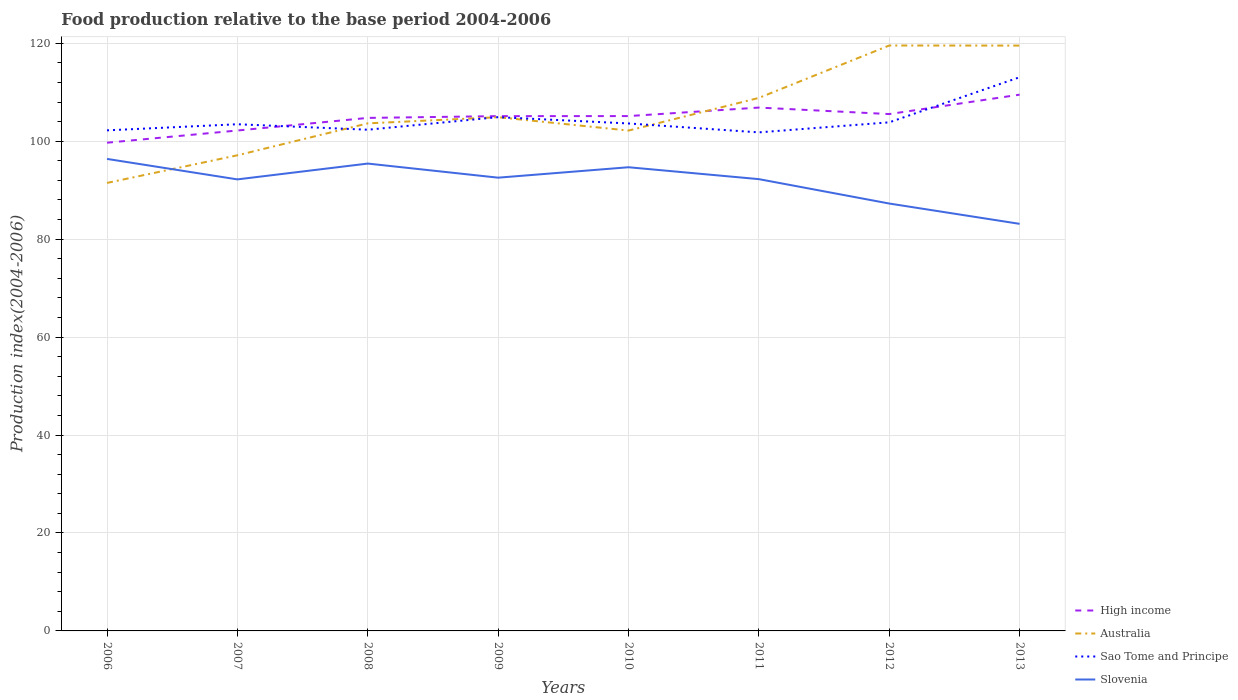How many different coloured lines are there?
Give a very brief answer. 4. Does the line corresponding to High income intersect with the line corresponding to Australia?
Provide a succinct answer. Yes. Across all years, what is the maximum food production index in Slovenia?
Provide a succinct answer. 83.12. In which year was the food production index in High income maximum?
Give a very brief answer. 2006. What is the total food production index in High income in the graph?
Keep it short and to the point. -3.96. What is the difference between the highest and the second highest food production index in High income?
Your answer should be compact. 9.81. How many years are there in the graph?
Give a very brief answer. 8. What is the difference between two consecutive major ticks on the Y-axis?
Your response must be concise. 20. Does the graph contain any zero values?
Ensure brevity in your answer.  No. Where does the legend appear in the graph?
Keep it short and to the point. Bottom right. How many legend labels are there?
Give a very brief answer. 4. How are the legend labels stacked?
Make the answer very short. Vertical. What is the title of the graph?
Make the answer very short. Food production relative to the base period 2004-2006. Does "Portugal" appear as one of the legend labels in the graph?
Keep it short and to the point. No. What is the label or title of the X-axis?
Give a very brief answer. Years. What is the label or title of the Y-axis?
Provide a short and direct response. Production index(2004-2006). What is the Production index(2004-2006) in High income in 2006?
Offer a terse response. 99.69. What is the Production index(2004-2006) of Australia in 2006?
Make the answer very short. 91.48. What is the Production index(2004-2006) of Sao Tome and Principe in 2006?
Keep it short and to the point. 102.21. What is the Production index(2004-2006) in Slovenia in 2006?
Make the answer very short. 96.38. What is the Production index(2004-2006) in High income in 2007?
Your answer should be compact. 102.18. What is the Production index(2004-2006) of Australia in 2007?
Offer a terse response. 97.12. What is the Production index(2004-2006) in Sao Tome and Principe in 2007?
Ensure brevity in your answer.  103.46. What is the Production index(2004-2006) of Slovenia in 2007?
Provide a succinct answer. 92.2. What is the Production index(2004-2006) in High income in 2008?
Your response must be concise. 104.75. What is the Production index(2004-2006) of Australia in 2008?
Keep it short and to the point. 103.64. What is the Production index(2004-2006) of Sao Tome and Principe in 2008?
Your answer should be compact. 102.34. What is the Production index(2004-2006) in Slovenia in 2008?
Your response must be concise. 95.43. What is the Production index(2004-2006) in High income in 2009?
Your response must be concise. 105.12. What is the Production index(2004-2006) of Australia in 2009?
Offer a terse response. 104.9. What is the Production index(2004-2006) of Sao Tome and Principe in 2009?
Offer a terse response. 104.91. What is the Production index(2004-2006) of Slovenia in 2009?
Provide a succinct answer. 92.55. What is the Production index(2004-2006) in High income in 2010?
Provide a short and direct response. 105.13. What is the Production index(2004-2006) of Australia in 2010?
Ensure brevity in your answer.  102.17. What is the Production index(2004-2006) in Sao Tome and Principe in 2010?
Your answer should be compact. 103.62. What is the Production index(2004-2006) of Slovenia in 2010?
Your answer should be very brief. 94.68. What is the Production index(2004-2006) of High income in 2011?
Your answer should be compact. 106.86. What is the Production index(2004-2006) of Australia in 2011?
Keep it short and to the point. 108.84. What is the Production index(2004-2006) in Sao Tome and Principe in 2011?
Offer a very short reply. 101.8. What is the Production index(2004-2006) in Slovenia in 2011?
Offer a terse response. 92.25. What is the Production index(2004-2006) of High income in 2012?
Your answer should be compact. 105.54. What is the Production index(2004-2006) of Australia in 2012?
Your answer should be very brief. 119.54. What is the Production index(2004-2006) of Sao Tome and Principe in 2012?
Your answer should be very brief. 103.85. What is the Production index(2004-2006) in Slovenia in 2012?
Provide a succinct answer. 87.27. What is the Production index(2004-2006) of High income in 2013?
Your answer should be compact. 109.5. What is the Production index(2004-2006) in Australia in 2013?
Your answer should be very brief. 119.52. What is the Production index(2004-2006) in Sao Tome and Principe in 2013?
Provide a succinct answer. 113.06. What is the Production index(2004-2006) in Slovenia in 2013?
Offer a very short reply. 83.12. Across all years, what is the maximum Production index(2004-2006) in High income?
Your response must be concise. 109.5. Across all years, what is the maximum Production index(2004-2006) of Australia?
Your response must be concise. 119.54. Across all years, what is the maximum Production index(2004-2006) in Sao Tome and Principe?
Keep it short and to the point. 113.06. Across all years, what is the maximum Production index(2004-2006) in Slovenia?
Your response must be concise. 96.38. Across all years, what is the minimum Production index(2004-2006) of High income?
Offer a very short reply. 99.69. Across all years, what is the minimum Production index(2004-2006) in Australia?
Keep it short and to the point. 91.48. Across all years, what is the minimum Production index(2004-2006) of Sao Tome and Principe?
Offer a terse response. 101.8. Across all years, what is the minimum Production index(2004-2006) of Slovenia?
Offer a terse response. 83.12. What is the total Production index(2004-2006) of High income in the graph?
Your response must be concise. 838.77. What is the total Production index(2004-2006) of Australia in the graph?
Make the answer very short. 847.21. What is the total Production index(2004-2006) of Sao Tome and Principe in the graph?
Offer a terse response. 835.25. What is the total Production index(2004-2006) of Slovenia in the graph?
Your answer should be very brief. 733.88. What is the difference between the Production index(2004-2006) of High income in 2006 and that in 2007?
Your response must be concise. -2.49. What is the difference between the Production index(2004-2006) in Australia in 2006 and that in 2007?
Offer a very short reply. -5.64. What is the difference between the Production index(2004-2006) in Sao Tome and Principe in 2006 and that in 2007?
Your answer should be very brief. -1.25. What is the difference between the Production index(2004-2006) in Slovenia in 2006 and that in 2007?
Ensure brevity in your answer.  4.18. What is the difference between the Production index(2004-2006) in High income in 2006 and that in 2008?
Offer a terse response. -5.06. What is the difference between the Production index(2004-2006) in Australia in 2006 and that in 2008?
Your answer should be compact. -12.16. What is the difference between the Production index(2004-2006) of Sao Tome and Principe in 2006 and that in 2008?
Keep it short and to the point. -0.13. What is the difference between the Production index(2004-2006) in Slovenia in 2006 and that in 2008?
Your answer should be very brief. 0.95. What is the difference between the Production index(2004-2006) of High income in 2006 and that in 2009?
Your answer should be very brief. -5.43. What is the difference between the Production index(2004-2006) in Australia in 2006 and that in 2009?
Provide a short and direct response. -13.42. What is the difference between the Production index(2004-2006) of Sao Tome and Principe in 2006 and that in 2009?
Give a very brief answer. -2.7. What is the difference between the Production index(2004-2006) of Slovenia in 2006 and that in 2009?
Give a very brief answer. 3.83. What is the difference between the Production index(2004-2006) in High income in 2006 and that in 2010?
Offer a terse response. -5.44. What is the difference between the Production index(2004-2006) of Australia in 2006 and that in 2010?
Give a very brief answer. -10.69. What is the difference between the Production index(2004-2006) in Sao Tome and Principe in 2006 and that in 2010?
Provide a succinct answer. -1.41. What is the difference between the Production index(2004-2006) of Slovenia in 2006 and that in 2010?
Offer a terse response. 1.7. What is the difference between the Production index(2004-2006) of High income in 2006 and that in 2011?
Offer a terse response. -7.17. What is the difference between the Production index(2004-2006) of Australia in 2006 and that in 2011?
Make the answer very short. -17.36. What is the difference between the Production index(2004-2006) in Sao Tome and Principe in 2006 and that in 2011?
Keep it short and to the point. 0.41. What is the difference between the Production index(2004-2006) in Slovenia in 2006 and that in 2011?
Give a very brief answer. 4.13. What is the difference between the Production index(2004-2006) of High income in 2006 and that in 2012?
Keep it short and to the point. -5.85. What is the difference between the Production index(2004-2006) in Australia in 2006 and that in 2012?
Provide a succinct answer. -28.06. What is the difference between the Production index(2004-2006) in Sao Tome and Principe in 2006 and that in 2012?
Your answer should be compact. -1.64. What is the difference between the Production index(2004-2006) of Slovenia in 2006 and that in 2012?
Your response must be concise. 9.11. What is the difference between the Production index(2004-2006) of High income in 2006 and that in 2013?
Your answer should be very brief. -9.81. What is the difference between the Production index(2004-2006) of Australia in 2006 and that in 2013?
Provide a short and direct response. -28.04. What is the difference between the Production index(2004-2006) in Sao Tome and Principe in 2006 and that in 2013?
Offer a very short reply. -10.85. What is the difference between the Production index(2004-2006) of Slovenia in 2006 and that in 2013?
Offer a very short reply. 13.26. What is the difference between the Production index(2004-2006) in High income in 2007 and that in 2008?
Provide a short and direct response. -2.57. What is the difference between the Production index(2004-2006) of Australia in 2007 and that in 2008?
Keep it short and to the point. -6.52. What is the difference between the Production index(2004-2006) in Sao Tome and Principe in 2007 and that in 2008?
Give a very brief answer. 1.12. What is the difference between the Production index(2004-2006) in Slovenia in 2007 and that in 2008?
Your answer should be very brief. -3.23. What is the difference between the Production index(2004-2006) of High income in 2007 and that in 2009?
Your response must be concise. -2.94. What is the difference between the Production index(2004-2006) of Australia in 2007 and that in 2009?
Offer a terse response. -7.78. What is the difference between the Production index(2004-2006) of Sao Tome and Principe in 2007 and that in 2009?
Give a very brief answer. -1.45. What is the difference between the Production index(2004-2006) in Slovenia in 2007 and that in 2009?
Provide a short and direct response. -0.35. What is the difference between the Production index(2004-2006) in High income in 2007 and that in 2010?
Your answer should be compact. -2.95. What is the difference between the Production index(2004-2006) in Australia in 2007 and that in 2010?
Provide a short and direct response. -5.05. What is the difference between the Production index(2004-2006) in Sao Tome and Principe in 2007 and that in 2010?
Your response must be concise. -0.16. What is the difference between the Production index(2004-2006) in Slovenia in 2007 and that in 2010?
Your answer should be compact. -2.48. What is the difference between the Production index(2004-2006) in High income in 2007 and that in 2011?
Offer a very short reply. -4.68. What is the difference between the Production index(2004-2006) in Australia in 2007 and that in 2011?
Your answer should be compact. -11.72. What is the difference between the Production index(2004-2006) of Sao Tome and Principe in 2007 and that in 2011?
Offer a very short reply. 1.66. What is the difference between the Production index(2004-2006) of Slovenia in 2007 and that in 2011?
Ensure brevity in your answer.  -0.05. What is the difference between the Production index(2004-2006) in High income in 2007 and that in 2012?
Provide a succinct answer. -3.36. What is the difference between the Production index(2004-2006) in Australia in 2007 and that in 2012?
Offer a very short reply. -22.42. What is the difference between the Production index(2004-2006) of Sao Tome and Principe in 2007 and that in 2012?
Offer a very short reply. -0.39. What is the difference between the Production index(2004-2006) of Slovenia in 2007 and that in 2012?
Your answer should be very brief. 4.93. What is the difference between the Production index(2004-2006) in High income in 2007 and that in 2013?
Your response must be concise. -7.32. What is the difference between the Production index(2004-2006) of Australia in 2007 and that in 2013?
Keep it short and to the point. -22.4. What is the difference between the Production index(2004-2006) in Slovenia in 2007 and that in 2013?
Provide a short and direct response. 9.08. What is the difference between the Production index(2004-2006) of High income in 2008 and that in 2009?
Provide a short and direct response. -0.36. What is the difference between the Production index(2004-2006) of Australia in 2008 and that in 2009?
Give a very brief answer. -1.26. What is the difference between the Production index(2004-2006) in Sao Tome and Principe in 2008 and that in 2009?
Offer a very short reply. -2.57. What is the difference between the Production index(2004-2006) of Slovenia in 2008 and that in 2009?
Keep it short and to the point. 2.88. What is the difference between the Production index(2004-2006) of High income in 2008 and that in 2010?
Ensure brevity in your answer.  -0.37. What is the difference between the Production index(2004-2006) in Australia in 2008 and that in 2010?
Provide a short and direct response. 1.47. What is the difference between the Production index(2004-2006) of Sao Tome and Principe in 2008 and that in 2010?
Your answer should be compact. -1.28. What is the difference between the Production index(2004-2006) of Slovenia in 2008 and that in 2010?
Offer a very short reply. 0.75. What is the difference between the Production index(2004-2006) of High income in 2008 and that in 2011?
Ensure brevity in your answer.  -2.11. What is the difference between the Production index(2004-2006) in Australia in 2008 and that in 2011?
Offer a terse response. -5.2. What is the difference between the Production index(2004-2006) in Sao Tome and Principe in 2008 and that in 2011?
Offer a terse response. 0.54. What is the difference between the Production index(2004-2006) in Slovenia in 2008 and that in 2011?
Offer a very short reply. 3.18. What is the difference between the Production index(2004-2006) in High income in 2008 and that in 2012?
Your answer should be very brief. -0.78. What is the difference between the Production index(2004-2006) in Australia in 2008 and that in 2012?
Provide a short and direct response. -15.9. What is the difference between the Production index(2004-2006) in Sao Tome and Principe in 2008 and that in 2012?
Your response must be concise. -1.51. What is the difference between the Production index(2004-2006) of Slovenia in 2008 and that in 2012?
Your answer should be compact. 8.16. What is the difference between the Production index(2004-2006) in High income in 2008 and that in 2013?
Ensure brevity in your answer.  -4.75. What is the difference between the Production index(2004-2006) of Australia in 2008 and that in 2013?
Give a very brief answer. -15.88. What is the difference between the Production index(2004-2006) in Sao Tome and Principe in 2008 and that in 2013?
Provide a short and direct response. -10.72. What is the difference between the Production index(2004-2006) in Slovenia in 2008 and that in 2013?
Offer a terse response. 12.31. What is the difference between the Production index(2004-2006) of High income in 2009 and that in 2010?
Offer a very short reply. -0.01. What is the difference between the Production index(2004-2006) in Australia in 2009 and that in 2010?
Offer a terse response. 2.73. What is the difference between the Production index(2004-2006) in Sao Tome and Principe in 2009 and that in 2010?
Your answer should be compact. 1.29. What is the difference between the Production index(2004-2006) of Slovenia in 2009 and that in 2010?
Your response must be concise. -2.13. What is the difference between the Production index(2004-2006) of High income in 2009 and that in 2011?
Ensure brevity in your answer.  -1.75. What is the difference between the Production index(2004-2006) in Australia in 2009 and that in 2011?
Provide a succinct answer. -3.94. What is the difference between the Production index(2004-2006) of Sao Tome and Principe in 2009 and that in 2011?
Your answer should be compact. 3.11. What is the difference between the Production index(2004-2006) in Slovenia in 2009 and that in 2011?
Ensure brevity in your answer.  0.3. What is the difference between the Production index(2004-2006) in High income in 2009 and that in 2012?
Give a very brief answer. -0.42. What is the difference between the Production index(2004-2006) in Australia in 2009 and that in 2012?
Ensure brevity in your answer.  -14.64. What is the difference between the Production index(2004-2006) in Sao Tome and Principe in 2009 and that in 2012?
Ensure brevity in your answer.  1.06. What is the difference between the Production index(2004-2006) of Slovenia in 2009 and that in 2012?
Your answer should be very brief. 5.28. What is the difference between the Production index(2004-2006) of High income in 2009 and that in 2013?
Provide a short and direct response. -4.39. What is the difference between the Production index(2004-2006) of Australia in 2009 and that in 2013?
Provide a succinct answer. -14.62. What is the difference between the Production index(2004-2006) of Sao Tome and Principe in 2009 and that in 2013?
Your response must be concise. -8.15. What is the difference between the Production index(2004-2006) in Slovenia in 2009 and that in 2013?
Keep it short and to the point. 9.43. What is the difference between the Production index(2004-2006) of High income in 2010 and that in 2011?
Offer a very short reply. -1.74. What is the difference between the Production index(2004-2006) in Australia in 2010 and that in 2011?
Give a very brief answer. -6.67. What is the difference between the Production index(2004-2006) in Sao Tome and Principe in 2010 and that in 2011?
Your response must be concise. 1.82. What is the difference between the Production index(2004-2006) in Slovenia in 2010 and that in 2011?
Your answer should be compact. 2.43. What is the difference between the Production index(2004-2006) in High income in 2010 and that in 2012?
Ensure brevity in your answer.  -0.41. What is the difference between the Production index(2004-2006) in Australia in 2010 and that in 2012?
Provide a succinct answer. -17.37. What is the difference between the Production index(2004-2006) of Sao Tome and Principe in 2010 and that in 2012?
Ensure brevity in your answer.  -0.23. What is the difference between the Production index(2004-2006) in Slovenia in 2010 and that in 2012?
Offer a terse response. 7.41. What is the difference between the Production index(2004-2006) in High income in 2010 and that in 2013?
Provide a succinct answer. -4.37. What is the difference between the Production index(2004-2006) of Australia in 2010 and that in 2013?
Ensure brevity in your answer.  -17.35. What is the difference between the Production index(2004-2006) in Sao Tome and Principe in 2010 and that in 2013?
Your response must be concise. -9.44. What is the difference between the Production index(2004-2006) of Slovenia in 2010 and that in 2013?
Ensure brevity in your answer.  11.56. What is the difference between the Production index(2004-2006) in High income in 2011 and that in 2012?
Your answer should be very brief. 1.33. What is the difference between the Production index(2004-2006) of Sao Tome and Principe in 2011 and that in 2012?
Provide a succinct answer. -2.05. What is the difference between the Production index(2004-2006) in Slovenia in 2011 and that in 2012?
Keep it short and to the point. 4.98. What is the difference between the Production index(2004-2006) of High income in 2011 and that in 2013?
Give a very brief answer. -2.64. What is the difference between the Production index(2004-2006) of Australia in 2011 and that in 2013?
Provide a succinct answer. -10.68. What is the difference between the Production index(2004-2006) of Sao Tome and Principe in 2011 and that in 2013?
Provide a succinct answer. -11.26. What is the difference between the Production index(2004-2006) of Slovenia in 2011 and that in 2013?
Your answer should be compact. 9.13. What is the difference between the Production index(2004-2006) in High income in 2012 and that in 2013?
Offer a terse response. -3.96. What is the difference between the Production index(2004-2006) in Australia in 2012 and that in 2013?
Your answer should be compact. 0.02. What is the difference between the Production index(2004-2006) in Sao Tome and Principe in 2012 and that in 2013?
Ensure brevity in your answer.  -9.21. What is the difference between the Production index(2004-2006) in Slovenia in 2012 and that in 2013?
Ensure brevity in your answer.  4.15. What is the difference between the Production index(2004-2006) of High income in 2006 and the Production index(2004-2006) of Australia in 2007?
Your answer should be very brief. 2.57. What is the difference between the Production index(2004-2006) of High income in 2006 and the Production index(2004-2006) of Sao Tome and Principe in 2007?
Your answer should be very brief. -3.77. What is the difference between the Production index(2004-2006) of High income in 2006 and the Production index(2004-2006) of Slovenia in 2007?
Give a very brief answer. 7.49. What is the difference between the Production index(2004-2006) in Australia in 2006 and the Production index(2004-2006) in Sao Tome and Principe in 2007?
Keep it short and to the point. -11.98. What is the difference between the Production index(2004-2006) of Australia in 2006 and the Production index(2004-2006) of Slovenia in 2007?
Your answer should be very brief. -0.72. What is the difference between the Production index(2004-2006) in Sao Tome and Principe in 2006 and the Production index(2004-2006) in Slovenia in 2007?
Your answer should be very brief. 10.01. What is the difference between the Production index(2004-2006) of High income in 2006 and the Production index(2004-2006) of Australia in 2008?
Make the answer very short. -3.95. What is the difference between the Production index(2004-2006) in High income in 2006 and the Production index(2004-2006) in Sao Tome and Principe in 2008?
Your answer should be compact. -2.65. What is the difference between the Production index(2004-2006) in High income in 2006 and the Production index(2004-2006) in Slovenia in 2008?
Your answer should be compact. 4.26. What is the difference between the Production index(2004-2006) of Australia in 2006 and the Production index(2004-2006) of Sao Tome and Principe in 2008?
Your answer should be compact. -10.86. What is the difference between the Production index(2004-2006) in Australia in 2006 and the Production index(2004-2006) in Slovenia in 2008?
Keep it short and to the point. -3.95. What is the difference between the Production index(2004-2006) of Sao Tome and Principe in 2006 and the Production index(2004-2006) of Slovenia in 2008?
Your answer should be compact. 6.78. What is the difference between the Production index(2004-2006) of High income in 2006 and the Production index(2004-2006) of Australia in 2009?
Provide a short and direct response. -5.21. What is the difference between the Production index(2004-2006) of High income in 2006 and the Production index(2004-2006) of Sao Tome and Principe in 2009?
Your response must be concise. -5.22. What is the difference between the Production index(2004-2006) in High income in 2006 and the Production index(2004-2006) in Slovenia in 2009?
Your answer should be compact. 7.14. What is the difference between the Production index(2004-2006) of Australia in 2006 and the Production index(2004-2006) of Sao Tome and Principe in 2009?
Keep it short and to the point. -13.43. What is the difference between the Production index(2004-2006) of Australia in 2006 and the Production index(2004-2006) of Slovenia in 2009?
Your answer should be compact. -1.07. What is the difference between the Production index(2004-2006) of Sao Tome and Principe in 2006 and the Production index(2004-2006) of Slovenia in 2009?
Keep it short and to the point. 9.66. What is the difference between the Production index(2004-2006) of High income in 2006 and the Production index(2004-2006) of Australia in 2010?
Your answer should be compact. -2.48. What is the difference between the Production index(2004-2006) of High income in 2006 and the Production index(2004-2006) of Sao Tome and Principe in 2010?
Provide a short and direct response. -3.93. What is the difference between the Production index(2004-2006) in High income in 2006 and the Production index(2004-2006) in Slovenia in 2010?
Your response must be concise. 5.01. What is the difference between the Production index(2004-2006) in Australia in 2006 and the Production index(2004-2006) in Sao Tome and Principe in 2010?
Provide a short and direct response. -12.14. What is the difference between the Production index(2004-2006) of Sao Tome and Principe in 2006 and the Production index(2004-2006) of Slovenia in 2010?
Provide a succinct answer. 7.53. What is the difference between the Production index(2004-2006) in High income in 2006 and the Production index(2004-2006) in Australia in 2011?
Keep it short and to the point. -9.15. What is the difference between the Production index(2004-2006) in High income in 2006 and the Production index(2004-2006) in Sao Tome and Principe in 2011?
Provide a succinct answer. -2.11. What is the difference between the Production index(2004-2006) in High income in 2006 and the Production index(2004-2006) in Slovenia in 2011?
Make the answer very short. 7.44. What is the difference between the Production index(2004-2006) in Australia in 2006 and the Production index(2004-2006) in Sao Tome and Principe in 2011?
Your answer should be compact. -10.32. What is the difference between the Production index(2004-2006) of Australia in 2006 and the Production index(2004-2006) of Slovenia in 2011?
Offer a very short reply. -0.77. What is the difference between the Production index(2004-2006) of Sao Tome and Principe in 2006 and the Production index(2004-2006) of Slovenia in 2011?
Provide a short and direct response. 9.96. What is the difference between the Production index(2004-2006) in High income in 2006 and the Production index(2004-2006) in Australia in 2012?
Keep it short and to the point. -19.85. What is the difference between the Production index(2004-2006) of High income in 2006 and the Production index(2004-2006) of Sao Tome and Principe in 2012?
Provide a succinct answer. -4.16. What is the difference between the Production index(2004-2006) of High income in 2006 and the Production index(2004-2006) of Slovenia in 2012?
Your answer should be compact. 12.42. What is the difference between the Production index(2004-2006) of Australia in 2006 and the Production index(2004-2006) of Sao Tome and Principe in 2012?
Give a very brief answer. -12.37. What is the difference between the Production index(2004-2006) in Australia in 2006 and the Production index(2004-2006) in Slovenia in 2012?
Provide a succinct answer. 4.21. What is the difference between the Production index(2004-2006) in Sao Tome and Principe in 2006 and the Production index(2004-2006) in Slovenia in 2012?
Your answer should be compact. 14.94. What is the difference between the Production index(2004-2006) in High income in 2006 and the Production index(2004-2006) in Australia in 2013?
Provide a short and direct response. -19.83. What is the difference between the Production index(2004-2006) of High income in 2006 and the Production index(2004-2006) of Sao Tome and Principe in 2013?
Make the answer very short. -13.37. What is the difference between the Production index(2004-2006) of High income in 2006 and the Production index(2004-2006) of Slovenia in 2013?
Ensure brevity in your answer.  16.57. What is the difference between the Production index(2004-2006) in Australia in 2006 and the Production index(2004-2006) in Sao Tome and Principe in 2013?
Give a very brief answer. -21.58. What is the difference between the Production index(2004-2006) in Australia in 2006 and the Production index(2004-2006) in Slovenia in 2013?
Provide a short and direct response. 8.36. What is the difference between the Production index(2004-2006) in Sao Tome and Principe in 2006 and the Production index(2004-2006) in Slovenia in 2013?
Your answer should be compact. 19.09. What is the difference between the Production index(2004-2006) of High income in 2007 and the Production index(2004-2006) of Australia in 2008?
Give a very brief answer. -1.46. What is the difference between the Production index(2004-2006) in High income in 2007 and the Production index(2004-2006) in Sao Tome and Principe in 2008?
Provide a succinct answer. -0.16. What is the difference between the Production index(2004-2006) of High income in 2007 and the Production index(2004-2006) of Slovenia in 2008?
Give a very brief answer. 6.75. What is the difference between the Production index(2004-2006) of Australia in 2007 and the Production index(2004-2006) of Sao Tome and Principe in 2008?
Make the answer very short. -5.22. What is the difference between the Production index(2004-2006) in Australia in 2007 and the Production index(2004-2006) in Slovenia in 2008?
Make the answer very short. 1.69. What is the difference between the Production index(2004-2006) in Sao Tome and Principe in 2007 and the Production index(2004-2006) in Slovenia in 2008?
Provide a short and direct response. 8.03. What is the difference between the Production index(2004-2006) of High income in 2007 and the Production index(2004-2006) of Australia in 2009?
Provide a succinct answer. -2.72. What is the difference between the Production index(2004-2006) in High income in 2007 and the Production index(2004-2006) in Sao Tome and Principe in 2009?
Your response must be concise. -2.73. What is the difference between the Production index(2004-2006) of High income in 2007 and the Production index(2004-2006) of Slovenia in 2009?
Offer a terse response. 9.63. What is the difference between the Production index(2004-2006) in Australia in 2007 and the Production index(2004-2006) in Sao Tome and Principe in 2009?
Make the answer very short. -7.79. What is the difference between the Production index(2004-2006) of Australia in 2007 and the Production index(2004-2006) of Slovenia in 2009?
Make the answer very short. 4.57. What is the difference between the Production index(2004-2006) of Sao Tome and Principe in 2007 and the Production index(2004-2006) of Slovenia in 2009?
Offer a terse response. 10.91. What is the difference between the Production index(2004-2006) of High income in 2007 and the Production index(2004-2006) of Australia in 2010?
Your response must be concise. 0.01. What is the difference between the Production index(2004-2006) in High income in 2007 and the Production index(2004-2006) in Sao Tome and Principe in 2010?
Provide a short and direct response. -1.44. What is the difference between the Production index(2004-2006) in High income in 2007 and the Production index(2004-2006) in Slovenia in 2010?
Provide a short and direct response. 7.5. What is the difference between the Production index(2004-2006) in Australia in 2007 and the Production index(2004-2006) in Sao Tome and Principe in 2010?
Provide a short and direct response. -6.5. What is the difference between the Production index(2004-2006) in Australia in 2007 and the Production index(2004-2006) in Slovenia in 2010?
Ensure brevity in your answer.  2.44. What is the difference between the Production index(2004-2006) in Sao Tome and Principe in 2007 and the Production index(2004-2006) in Slovenia in 2010?
Keep it short and to the point. 8.78. What is the difference between the Production index(2004-2006) in High income in 2007 and the Production index(2004-2006) in Australia in 2011?
Your response must be concise. -6.66. What is the difference between the Production index(2004-2006) in High income in 2007 and the Production index(2004-2006) in Sao Tome and Principe in 2011?
Your answer should be very brief. 0.38. What is the difference between the Production index(2004-2006) of High income in 2007 and the Production index(2004-2006) of Slovenia in 2011?
Your answer should be very brief. 9.93. What is the difference between the Production index(2004-2006) in Australia in 2007 and the Production index(2004-2006) in Sao Tome and Principe in 2011?
Provide a succinct answer. -4.68. What is the difference between the Production index(2004-2006) of Australia in 2007 and the Production index(2004-2006) of Slovenia in 2011?
Provide a short and direct response. 4.87. What is the difference between the Production index(2004-2006) in Sao Tome and Principe in 2007 and the Production index(2004-2006) in Slovenia in 2011?
Make the answer very short. 11.21. What is the difference between the Production index(2004-2006) of High income in 2007 and the Production index(2004-2006) of Australia in 2012?
Provide a succinct answer. -17.36. What is the difference between the Production index(2004-2006) of High income in 2007 and the Production index(2004-2006) of Sao Tome and Principe in 2012?
Offer a terse response. -1.67. What is the difference between the Production index(2004-2006) of High income in 2007 and the Production index(2004-2006) of Slovenia in 2012?
Make the answer very short. 14.91. What is the difference between the Production index(2004-2006) in Australia in 2007 and the Production index(2004-2006) in Sao Tome and Principe in 2012?
Your response must be concise. -6.73. What is the difference between the Production index(2004-2006) of Australia in 2007 and the Production index(2004-2006) of Slovenia in 2012?
Make the answer very short. 9.85. What is the difference between the Production index(2004-2006) in Sao Tome and Principe in 2007 and the Production index(2004-2006) in Slovenia in 2012?
Give a very brief answer. 16.19. What is the difference between the Production index(2004-2006) of High income in 2007 and the Production index(2004-2006) of Australia in 2013?
Offer a very short reply. -17.34. What is the difference between the Production index(2004-2006) in High income in 2007 and the Production index(2004-2006) in Sao Tome and Principe in 2013?
Your answer should be very brief. -10.88. What is the difference between the Production index(2004-2006) in High income in 2007 and the Production index(2004-2006) in Slovenia in 2013?
Your answer should be compact. 19.06. What is the difference between the Production index(2004-2006) in Australia in 2007 and the Production index(2004-2006) in Sao Tome and Principe in 2013?
Your answer should be compact. -15.94. What is the difference between the Production index(2004-2006) of Australia in 2007 and the Production index(2004-2006) of Slovenia in 2013?
Make the answer very short. 14. What is the difference between the Production index(2004-2006) in Sao Tome and Principe in 2007 and the Production index(2004-2006) in Slovenia in 2013?
Your answer should be very brief. 20.34. What is the difference between the Production index(2004-2006) of High income in 2008 and the Production index(2004-2006) of Australia in 2009?
Make the answer very short. -0.15. What is the difference between the Production index(2004-2006) of High income in 2008 and the Production index(2004-2006) of Sao Tome and Principe in 2009?
Your response must be concise. -0.16. What is the difference between the Production index(2004-2006) in High income in 2008 and the Production index(2004-2006) in Slovenia in 2009?
Ensure brevity in your answer.  12.2. What is the difference between the Production index(2004-2006) of Australia in 2008 and the Production index(2004-2006) of Sao Tome and Principe in 2009?
Make the answer very short. -1.27. What is the difference between the Production index(2004-2006) in Australia in 2008 and the Production index(2004-2006) in Slovenia in 2009?
Make the answer very short. 11.09. What is the difference between the Production index(2004-2006) in Sao Tome and Principe in 2008 and the Production index(2004-2006) in Slovenia in 2009?
Make the answer very short. 9.79. What is the difference between the Production index(2004-2006) in High income in 2008 and the Production index(2004-2006) in Australia in 2010?
Offer a terse response. 2.58. What is the difference between the Production index(2004-2006) in High income in 2008 and the Production index(2004-2006) in Sao Tome and Principe in 2010?
Offer a very short reply. 1.13. What is the difference between the Production index(2004-2006) of High income in 2008 and the Production index(2004-2006) of Slovenia in 2010?
Your response must be concise. 10.07. What is the difference between the Production index(2004-2006) of Australia in 2008 and the Production index(2004-2006) of Sao Tome and Principe in 2010?
Your answer should be compact. 0.02. What is the difference between the Production index(2004-2006) of Australia in 2008 and the Production index(2004-2006) of Slovenia in 2010?
Make the answer very short. 8.96. What is the difference between the Production index(2004-2006) in Sao Tome and Principe in 2008 and the Production index(2004-2006) in Slovenia in 2010?
Your answer should be very brief. 7.66. What is the difference between the Production index(2004-2006) in High income in 2008 and the Production index(2004-2006) in Australia in 2011?
Offer a very short reply. -4.09. What is the difference between the Production index(2004-2006) in High income in 2008 and the Production index(2004-2006) in Sao Tome and Principe in 2011?
Your answer should be compact. 2.95. What is the difference between the Production index(2004-2006) in High income in 2008 and the Production index(2004-2006) in Slovenia in 2011?
Offer a terse response. 12.5. What is the difference between the Production index(2004-2006) in Australia in 2008 and the Production index(2004-2006) in Sao Tome and Principe in 2011?
Offer a terse response. 1.84. What is the difference between the Production index(2004-2006) in Australia in 2008 and the Production index(2004-2006) in Slovenia in 2011?
Make the answer very short. 11.39. What is the difference between the Production index(2004-2006) of Sao Tome and Principe in 2008 and the Production index(2004-2006) of Slovenia in 2011?
Offer a terse response. 10.09. What is the difference between the Production index(2004-2006) of High income in 2008 and the Production index(2004-2006) of Australia in 2012?
Your response must be concise. -14.79. What is the difference between the Production index(2004-2006) of High income in 2008 and the Production index(2004-2006) of Sao Tome and Principe in 2012?
Ensure brevity in your answer.  0.9. What is the difference between the Production index(2004-2006) of High income in 2008 and the Production index(2004-2006) of Slovenia in 2012?
Provide a short and direct response. 17.48. What is the difference between the Production index(2004-2006) of Australia in 2008 and the Production index(2004-2006) of Sao Tome and Principe in 2012?
Your answer should be very brief. -0.21. What is the difference between the Production index(2004-2006) in Australia in 2008 and the Production index(2004-2006) in Slovenia in 2012?
Your answer should be very brief. 16.37. What is the difference between the Production index(2004-2006) of Sao Tome and Principe in 2008 and the Production index(2004-2006) of Slovenia in 2012?
Your response must be concise. 15.07. What is the difference between the Production index(2004-2006) of High income in 2008 and the Production index(2004-2006) of Australia in 2013?
Offer a terse response. -14.77. What is the difference between the Production index(2004-2006) of High income in 2008 and the Production index(2004-2006) of Sao Tome and Principe in 2013?
Provide a succinct answer. -8.31. What is the difference between the Production index(2004-2006) in High income in 2008 and the Production index(2004-2006) in Slovenia in 2013?
Offer a very short reply. 21.63. What is the difference between the Production index(2004-2006) of Australia in 2008 and the Production index(2004-2006) of Sao Tome and Principe in 2013?
Make the answer very short. -9.42. What is the difference between the Production index(2004-2006) in Australia in 2008 and the Production index(2004-2006) in Slovenia in 2013?
Your answer should be very brief. 20.52. What is the difference between the Production index(2004-2006) in Sao Tome and Principe in 2008 and the Production index(2004-2006) in Slovenia in 2013?
Provide a short and direct response. 19.22. What is the difference between the Production index(2004-2006) of High income in 2009 and the Production index(2004-2006) of Australia in 2010?
Your answer should be compact. 2.95. What is the difference between the Production index(2004-2006) of High income in 2009 and the Production index(2004-2006) of Sao Tome and Principe in 2010?
Provide a short and direct response. 1.5. What is the difference between the Production index(2004-2006) of High income in 2009 and the Production index(2004-2006) of Slovenia in 2010?
Provide a short and direct response. 10.44. What is the difference between the Production index(2004-2006) in Australia in 2009 and the Production index(2004-2006) in Sao Tome and Principe in 2010?
Give a very brief answer. 1.28. What is the difference between the Production index(2004-2006) of Australia in 2009 and the Production index(2004-2006) of Slovenia in 2010?
Make the answer very short. 10.22. What is the difference between the Production index(2004-2006) of Sao Tome and Principe in 2009 and the Production index(2004-2006) of Slovenia in 2010?
Give a very brief answer. 10.23. What is the difference between the Production index(2004-2006) in High income in 2009 and the Production index(2004-2006) in Australia in 2011?
Offer a terse response. -3.72. What is the difference between the Production index(2004-2006) in High income in 2009 and the Production index(2004-2006) in Sao Tome and Principe in 2011?
Ensure brevity in your answer.  3.32. What is the difference between the Production index(2004-2006) of High income in 2009 and the Production index(2004-2006) of Slovenia in 2011?
Your answer should be very brief. 12.87. What is the difference between the Production index(2004-2006) of Australia in 2009 and the Production index(2004-2006) of Slovenia in 2011?
Provide a short and direct response. 12.65. What is the difference between the Production index(2004-2006) of Sao Tome and Principe in 2009 and the Production index(2004-2006) of Slovenia in 2011?
Keep it short and to the point. 12.66. What is the difference between the Production index(2004-2006) in High income in 2009 and the Production index(2004-2006) in Australia in 2012?
Your answer should be very brief. -14.42. What is the difference between the Production index(2004-2006) in High income in 2009 and the Production index(2004-2006) in Sao Tome and Principe in 2012?
Your answer should be compact. 1.27. What is the difference between the Production index(2004-2006) in High income in 2009 and the Production index(2004-2006) in Slovenia in 2012?
Your response must be concise. 17.85. What is the difference between the Production index(2004-2006) in Australia in 2009 and the Production index(2004-2006) in Sao Tome and Principe in 2012?
Offer a very short reply. 1.05. What is the difference between the Production index(2004-2006) in Australia in 2009 and the Production index(2004-2006) in Slovenia in 2012?
Ensure brevity in your answer.  17.63. What is the difference between the Production index(2004-2006) of Sao Tome and Principe in 2009 and the Production index(2004-2006) of Slovenia in 2012?
Provide a short and direct response. 17.64. What is the difference between the Production index(2004-2006) of High income in 2009 and the Production index(2004-2006) of Australia in 2013?
Keep it short and to the point. -14.4. What is the difference between the Production index(2004-2006) of High income in 2009 and the Production index(2004-2006) of Sao Tome and Principe in 2013?
Your response must be concise. -7.94. What is the difference between the Production index(2004-2006) of High income in 2009 and the Production index(2004-2006) of Slovenia in 2013?
Offer a very short reply. 22. What is the difference between the Production index(2004-2006) of Australia in 2009 and the Production index(2004-2006) of Sao Tome and Principe in 2013?
Your answer should be compact. -8.16. What is the difference between the Production index(2004-2006) of Australia in 2009 and the Production index(2004-2006) of Slovenia in 2013?
Make the answer very short. 21.78. What is the difference between the Production index(2004-2006) of Sao Tome and Principe in 2009 and the Production index(2004-2006) of Slovenia in 2013?
Ensure brevity in your answer.  21.79. What is the difference between the Production index(2004-2006) in High income in 2010 and the Production index(2004-2006) in Australia in 2011?
Make the answer very short. -3.71. What is the difference between the Production index(2004-2006) of High income in 2010 and the Production index(2004-2006) of Sao Tome and Principe in 2011?
Give a very brief answer. 3.33. What is the difference between the Production index(2004-2006) of High income in 2010 and the Production index(2004-2006) of Slovenia in 2011?
Offer a terse response. 12.88. What is the difference between the Production index(2004-2006) of Australia in 2010 and the Production index(2004-2006) of Sao Tome and Principe in 2011?
Make the answer very short. 0.37. What is the difference between the Production index(2004-2006) in Australia in 2010 and the Production index(2004-2006) in Slovenia in 2011?
Provide a short and direct response. 9.92. What is the difference between the Production index(2004-2006) of Sao Tome and Principe in 2010 and the Production index(2004-2006) of Slovenia in 2011?
Provide a succinct answer. 11.37. What is the difference between the Production index(2004-2006) in High income in 2010 and the Production index(2004-2006) in Australia in 2012?
Provide a succinct answer. -14.41. What is the difference between the Production index(2004-2006) in High income in 2010 and the Production index(2004-2006) in Sao Tome and Principe in 2012?
Ensure brevity in your answer.  1.28. What is the difference between the Production index(2004-2006) in High income in 2010 and the Production index(2004-2006) in Slovenia in 2012?
Offer a terse response. 17.86. What is the difference between the Production index(2004-2006) of Australia in 2010 and the Production index(2004-2006) of Sao Tome and Principe in 2012?
Your response must be concise. -1.68. What is the difference between the Production index(2004-2006) of Australia in 2010 and the Production index(2004-2006) of Slovenia in 2012?
Your response must be concise. 14.9. What is the difference between the Production index(2004-2006) in Sao Tome and Principe in 2010 and the Production index(2004-2006) in Slovenia in 2012?
Provide a succinct answer. 16.35. What is the difference between the Production index(2004-2006) in High income in 2010 and the Production index(2004-2006) in Australia in 2013?
Offer a terse response. -14.39. What is the difference between the Production index(2004-2006) in High income in 2010 and the Production index(2004-2006) in Sao Tome and Principe in 2013?
Provide a short and direct response. -7.93. What is the difference between the Production index(2004-2006) of High income in 2010 and the Production index(2004-2006) of Slovenia in 2013?
Make the answer very short. 22.01. What is the difference between the Production index(2004-2006) in Australia in 2010 and the Production index(2004-2006) in Sao Tome and Principe in 2013?
Your response must be concise. -10.89. What is the difference between the Production index(2004-2006) in Australia in 2010 and the Production index(2004-2006) in Slovenia in 2013?
Provide a succinct answer. 19.05. What is the difference between the Production index(2004-2006) in High income in 2011 and the Production index(2004-2006) in Australia in 2012?
Offer a very short reply. -12.68. What is the difference between the Production index(2004-2006) of High income in 2011 and the Production index(2004-2006) of Sao Tome and Principe in 2012?
Keep it short and to the point. 3.01. What is the difference between the Production index(2004-2006) in High income in 2011 and the Production index(2004-2006) in Slovenia in 2012?
Your answer should be very brief. 19.59. What is the difference between the Production index(2004-2006) in Australia in 2011 and the Production index(2004-2006) in Sao Tome and Principe in 2012?
Give a very brief answer. 4.99. What is the difference between the Production index(2004-2006) of Australia in 2011 and the Production index(2004-2006) of Slovenia in 2012?
Your answer should be compact. 21.57. What is the difference between the Production index(2004-2006) of Sao Tome and Principe in 2011 and the Production index(2004-2006) of Slovenia in 2012?
Your answer should be very brief. 14.53. What is the difference between the Production index(2004-2006) in High income in 2011 and the Production index(2004-2006) in Australia in 2013?
Provide a short and direct response. -12.66. What is the difference between the Production index(2004-2006) of High income in 2011 and the Production index(2004-2006) of Sao Tome and Principe in 2013?
Your answer should be compact. -6.2. What is the difference between the Production index(2004-2006) in High income in 2011 and the Production index(2004-2006) in Slovenia in 2013?
Offer a terse response. 23.74. What is the difference between the Production index(2004-2006) in Australia in 2011 and the Production index(2004-2006) in Sao Tome and Principe in 2013?
Ensure brevity in your answer.  -4.22. What is the difference between the Production index(2004-2006) of Australia in 2011 and the Production index(2004-2006) of Slovenia in 2013?
Give a very brief answer. 25.72. What is the difference between the Production index(2004-2006) of Sao Tome and Principe in 2011 and the Production index(2004-2006) of Slovenia in 2013?
Provide a succinct answer. 18.68. What is the difference between the Production index(2004-2006) in High income in 2012 and the Production index(2004-2006) in Australia in 2013?
Your answer should be very brief. -13.98. What is the difference between the Production index(2004-2006) of High income in 2012 and the Production index(2004-2006) of Sao Tome and Principe in 2013?
Provide a succinct answer. -7.52. What is the difference between the Production index(2004-2006) of High income in 2012 and the Production index(2004-2006) of Slovenia in 2013?
Your answer should be very brief. 22.42. What is the difference between the Production index(2004-2006) in Australia in 2012 and the Production index(2004-2006) in Sao Tome and Principe in 2013?
Your response must be concise. 6.48. What is the difference between the Production index(2004-2006) in Australia in 2012 and the Production index(2004-2006) in Slovenia in 2013?
Provide a succinct answer. 36.42. What is the difference between the Production index(2004-2006) in Sao Tome and Principe in 2012 and the Production index(2004-2006) in Slovenia in 2013?
Provide a short and direct response. 20.73. What is the average Production index(2004-2006) in High income per year?
Offer a very short reply. 104.85. What is the average Production index(2004-2006) in Australia per year?
Provide a short and direct response. 105.9. What is the average Production index(2004-2006) in Sao Tome and Principe per year?
Offer a terse response. 104.41. What is the average Production index(2004-2006) in Slovenia per year?
Give a very brief answer. 91.73. In the year 2006, what is the difference between the Production index(2004-2006) of High income and Production index(2004-2006) of Australia?
Keep it short and to the point. 8.21. In the year 2006, what is the difference between the Production index(2004-2006) of High income and Production index(2004-2006) of Sao Tome and Principe?
Offer a terse response. -2.52. In the year 2006, what is the difference between the Production index(2004-2006) in High income and Production index(2004-2006) in Slovenia?
Provide a short and direct response. 3.31. In the year 2006, what is the difference between the Production index(2004-2006) of Australia and Production index(2004-2006) of Sao Tome and Principe?
Make the answer very short. -10.73. In the year 2006, what is the difference between the Production index(2004-2006) of Sao Tome and Principe and Production index(2004-2006) of Slovenia?
Provide a succinct answer. 5.83. In the year 2007, what is the difference between the Production index(2004-2006) of High income and Production index(2004-2006) of Australia?
Provide a succinct answer. 5.06. In the year 2007, what is the difference between the Production index(2004-2006) of High income and Production index(2004-2006) of Sao Tome and Principe?
Your response must be concise. -1.28. In the year 2007, what is the difference between the Production index(2004-2006) in High income and Production index(2004-2006) in Slovenia?
Provide a succinct answer. 9.98. In the year 2007, what is the difference between the Production index(2004-2006) in Australia and Production index(2004-2006) in Sao Tome and Principe?
Make the answer very short. -6.34. In the year 2007, what is the difference between the Production index(2004-2006) of Australia and Production index(2004-2006) of Slovenia?
Make the answer very short. 4.92. In the year 2007, what is the difference between the Production index(2004-2006) in Sao Tome and Principe and Production index(2004-2006) in Slovenia?
Your response must be concise. 11.26. In the year 2008, what is the difference between the Production index(2004-2006) in High income and Production index(2004-2006) in Australia?
Provide a succinct answer. 1.11. In the year 2008, what is the difference between the Production index(2004-2006) in High income and Production index(2004-2006) in Sao Tome and Principe?
Your answer should be compact. 2.41. In the year 2008, what is the difference between the Production index(2004-2006) of High income and Production index(2004-2006) of Slovenia?
Your answer should be very brief. 9.32. In the year 2008, what is the difference between the Production index(2004-2006) in Australia and Production index(2004-2006) in Slovenia?
Provide a short and direct response. 8.21. In the year 2008, what is the difference between the Production index(2004-2006) in Sao Tome and Principe and Production index(2004-2006) in Slovenia?
Provide a succinct answer. 6.91. In the year 2009, what is the difference between the Production index(2004-2006) of High income and Production index(2004-2006) of Australia?
Your answer should be compact. 0.22. In the year 2009, what is the difference between the Production index(2004-2006) of High income and Production index(2004-2006) of Sao Tome and Principe?
Keep it short and to the point. 0.21. In the year 2009, what is the difference between the Production index(2004-2006) in High income and Production index(2004-2006) in Slovenia?
Ensure brevity in your answer.  12.57. In the year 2009, what is the difference between the Production index(2004-2006) in Australia and Production index(2004-2006) in Sao Tome and Principe?
Offer a very short reply. -0.01. In the year 2009, what is the difference between the Production index(2004-2006) in Australia and Production index(2004-2006) in Slovenia?
Offer a very short reply. 12.35. In the year 2009, what is the difference between the Production index(2004-2006) in Sao Tome and Principe and Production index(2004-2006) in Slovenia?
Give a very brief answer. 12.36. In the year 2010, what is the difference between the Production index(2004-2006) in High income and Production index(2004-2006) in Australia?
Offer a very short reply. 2.96. In the year 2010, what is the difference between the Production index(2004-2006) of High income and Production index(2004-2006) of Sao Tome and Principe?
Your response must be concise. 1.51. In the year 2010, what is the difference between the Production index(2004-2006) of High income and Production index(2004-2006) of Slovenia?
Provide a short and direct response. 10.45. In the year 2010, what is the difference between the Production index(2004-2006) in Australia and Production index(2004-2006) in Sao Tome and Principe?
Ensure brevity in your answer.  -1.45. In the year 2010, what is the difference between the Production index(2004-2006) of Australia and Production index(2004-2006) of Slovenia?
Your answer should be compact. 7.49. In the year 2010, what is the difference between the Production index(2004-2006) in Sao Tome and Principe and Production index(2004-2006) in Slovenia?
Give a very brief answer. 8.94. In the year 2011, what is the difference between the Production index(2004-2006) in High income and Production index(2004-2006) in Australia?
Offer a very short reply. -1.98. In the year 2011, what is the difference between the Production index(2004-2006) in High income and Production index(2004-2006) in Sao Tome and Principe?
Give a very brief answer. 5.06. In the year 2011, what is the difference between the Production index(2004-2006) in High income and Production index(2004-2006) in Slovenia?
Your answer should be very brief. 14.61. In the year 2011, what is the difference between the Production index(2004-2006) of Australia and Production index(2004-2006) of Sao Tome and Principe?
Provide a short and direct response. 7.04. In the year 2011, what is the difference between the Production index(2004-2006) of Australia and Production index(2004-2006) of Slovenia?
Your answer should be very brief. 16.59. In the year 2011, what is the difference between the Production index(2004-2006) in Sao Tome and Principe and Production index(2004-2006) in Slovenia?
Your answer should be compact. 9.55. In the year 2012, what is the difference between the Production index(2004-2006) of High income and Production index(2004-2006) of Australia?
Keep it short and to the point. -14. In the year 2012, what is the difference between the Production index(2004-2006) in High income and Production index(2004-2006) in Sao Tome and Principe?
Keep it short and to the point. 1.69. In the year 2012, what is the difference between the Production index(2004-2006) in High income and Production index(2004-2006) in Slovenia?
Give a very brief answer. 18.27. In the year 2012, what is the difference between the Production index(2004-2006) in Australia and Production index(2004-2006) in Sao Tome and Principe?
Your answer should be compact. 15.69. In the year 2012, what is the difference between the Production index(2004-2006) in Australia and Production index(2004-2006) in Slovenia?
Make the answer very short. 32.27. In the year 2012, what is the difference between the Production index(2004-2006) in Sao Tome and Principe and Production index(2004-2006) in Slovenia?
Offer a very short reply. 16.58. In the year 2013, what is the difference between the Production index(2004-2006) in High income and Production index(2004-2006) in Australia?
Keep it short and to the point. -10.02. In the year 2013, what is the difference between the Production index(2004-2006) of High income and Production index(2004-2006) of Sao Tome and Principe?
Ensure brevity in your answer.  -3.56. In the year 2013, what is the difference between the Production index(2004-2006) in High income and Production index(2004-2006) in Slovenia?
Give a very brief answer. 26.38. In the year 2013, what is the difference between the Production index(2004-2006) of Australia and Production index(2004-2006) of Sao Tome and Principe?
Your answer should be compact. 6.46. In the year 2013, what is the difference between the Production index(2004-2006) of Australia and Production index(2004-2006) of Slovenia?
Your response must be concise. 36.4. In the year 2013, what is the difference between the Production index(2004-2006) of Sao Tome and Principe and Production index(2004-2006) of Slovenia?
Provide a short and direct response. 29.94. What is the ratio of the Production index(2004-2006) of High income in 2006 to that in 2007?
Provide a succinct answer. 0.98. What is the ratio of the Production index(2004-2006) in Australia in 2006 to that in 2007?
Provide a short and direct response. 0.94. What is the ratio of the Production index(2004-2006) in Sao Tome and Principe in 2006 to that in 2007?
Keep it short and to the point. 0.99. What is the ratio of the Production index(2004-2006) of Slovenia in 2006 to that in 2007?
Offer a very short reply. 1.05. What is the ratio of the Production index(2004-2006) of High income in 2006 to that in 2008?
Provide a succinct answer. 0.95. What is the ratio of the Production index(2004-2006) of Australia in 2006 to that in 2008?
Provide a short and direct response. 0.88. What is the ratio of the Production index(2004-2006) in Slovenia in 2006 to that in 2008?
Make the answer very short. 1.01. What is the ratio of the Production index(2004-2006) in High income in 2006 to that in 2009?
Ensure brevity in your answer.  0.95. What is the ratio of the Production index(2004-2006) in Australia in 2006 to that in 2009?
Make the answer very short. 0.87. What is the ratio of the Production index(2004-2006) in Sao Tome and Principe in 2006 to that in 2009?
Your response must be concise. 0.97. What is the ratio of the Production index(2004-2006) of Slovenia in 2006 to that in 2009?
Offer a terse response. 1.04. What is the ratio of the Production index(2004-2006) in High income in 2006 to that in 2010?
Keep it short and to the point. 0.95. What is the ratio of the Production index(2004-2006) of Australia in 2006 to that in 2010?
Your answer should be very brief. 0.9. What is the ratio of the Production index(2004-2006) of Sao Tome and Principe in 2006 to that in 2010?
Give a very brief answer. 0.99. What is the ratio of the Production index(2004-2006) in Slovenia in 2006 to that in 2010?
Your answer should be compact. 1.02. What is the ratio of the Production index(2004-2006) of High income in 2006 to that in 2011?
Your answer should be very brief. 0.93. What is the ratio of the Production index(2004-2006) of Australia in 2006 to that in 2011?
Provide a succinct answer. 0.84. What is the ratio of the Production index(2004-2006) of Sao Tome and Principe in 2006 to that in 2011?
Provide a short and direct response. 1. What is the ratio of the Production index(2004-2006) of Slovenia in 2006 to that in 2011?
Make the answer very short. 1.04. What is the ratio of the Production index(2004-2006) of High income in 2006 to that in 2012?
Keep it short and to the point. 0.94. What is the ratio of the Production index(2004-2006) in Australia in 2006 to that in 2012?
Ensure brevity in your answer.  0.77. What is the ratio of the Production index(2004-2006) of Sao Tome and Principe in 2006 to that in 2012?
Offer a terse response. 0.98. What is the ratio of the Production index(2004-2006) of Slovenia in 2006 to that in 2012?
Provide a succinct answer. 1.1. What is the ratio of the Production index(2004-2006) of High income in 2006 to that in 2013?
Your response must be concise. 0.91. What is the ratio of the Production index(2004-2006) of Australia in 2006 to that in 2013?
Ensure brevity in your answer.  0.77. What is the ratio of the Production index(2004-2006) of Sao Tome and Principe in 2006 to that in 2013?
Your answer should be compact. 0.9. What is the ratio of the Production index(2004-2006) of Slovenia in 2006 to that in 2013?
Give a very brief answer. 1.16. What is the ratio of the Production index(2004-2006) of High income in 2007 to that in 2008?
Give a very brief answer. 0.98. What is the ratio of the Production index(2004-2006) of Australia in 2007 to that in 2008?
Offer a very short reply. 0.94. What is the ratio of the Production index(2004-2006) in Sao Tome and Principe in 2007 to that in 2008?
Provide a succinct answer. 1.01. What is the ratio of the Production index(2004-2006) in Slovenia in 2007 to that in 2008?
Your response must be concise. 0.97. What is the ratio of the Production index(2004-2006) in High income in 2007 to that in 2009?
Keep it short and to the point. 0.97. What is the ratio of the Production index(2004-2006) of Australia in 2007 to that in 2009?
Your answer should be very brief. 0.93. What is the ratio of the Production index(2004-2006) in Sao Tome and Principe in 2007 to that in 2009?
Offer a very short reply. 0.99. What is the ratio of the Production index(2004-2006) in High income in 2007 to that in 2010?
Your answer should be compact. 0.97. What is the ratio of the Production index(2004-2006) of Australia in 2007 to that in 2010?
Your answer should be compact. 0.95. What is the ratio of the Production index(2004-2006) of Slovenia in 2007 to that in 2010?
Ensure brevity in your answer.  0.97. What is the ratio of the Production index(2004-2006) in High income in 2007 to that in 2011?
Your answer should be very brief. 0.96. What is the ratio of the Production index(2004-2006) in Australia in 2007 to that in 2011?
Your response must be concise. 0.89. What is the ratio of the Production index(2004-2006) of Sao Tome and Principe in 2007 to that in 2011?
Give a very brief answer. 1.02. What is the ratio of the Production index(2004-2006) of Slovenia in 2007 to that in 2011?
Keep it short and to the point. 1. What is the ratio of the Production index(2004-2006) in High income in 2007 to that in 2012?
Offer a terse response. 0.97. What is the ratio of the Production index(2004-2006) of Australia in 2007 to that in 2012?
Keep it short and to the point. 0.81. What is the ratio of the Production index(2004-2006) in Sao Tome and Principe in 2007 to that in 2012?
Give a very brief answer. 1. What is the ratio of the Production index(2004-2006) in Slovenia in 2007 to that in 2012?
Make the answer very short. 1.06. What is the ratio of the Production index(2004-2006) in High income in 2007 to that in 2013?
Make the answer very short. 0.93. What is the ratio of the Production index(2004-2006) of Australia in 2007 to that in 2013?
Make the answer very short. 0.81. What is the ratio of the Production index(2004-2006) of Sao Tome and Principe in 2007 to that in 2013?
Make the answer very short. 0.92. What is the ratio of the Production index(2004-2006) in Slovenia in 2007 to that in 2013?
Give a very brief answer. 1.11. What is the ratio of the Production index(2004-2006) in Australia in 2008 to that in 2009?
Offer a very short reply. 0.99. What is the ratio of the Production index(2004-2006) of Sao Tome and Principe in 2008 to that in 2009?
Your response must be concise. 0.98. What is the ratio of the Production index(2004-2006) in Slovenia in 2008 to that in 2009?
Offer a terse response. 1.03. What is the ratio of the Production index(2004-2006) of High income in 2008 to that in 2010?
Offer a terse response. 1. What is the ratio of the Production index(2004-2006) of Australia in 2008 to that in 2010?
Your answer should be very brief. 1.01. What is the ratio of the Production index(2004-2006) in Sao Tome and Principe in 2008 to that in 2010?
Your answer should be compact. 0.99. What is the ratio of the Production index(2004-2006) of Slovenia in 2008 to that in 2010?
Provide a succinct answer. 1.01. What is the ratio of the Production index(2004-2006) in High income in 2008 to that in 2011?
Give a very brief answer. 0.98. What is the ratio of the Production index(2004-2006) of Australia in 2008 to that in 2011?
Offer a very short reply. 0.95. What is the ratio of the Production index(2004-2006) of Slovenia in 2008 to that in 2011?
Give a very brief answer. 1.03. What is the ratio of the Production index(2004-2006) in High income in 2008 to that in 2012?
Your answer should be very brief. 0.99. What is the ratio of the Production index(2004-2006) in Australia in 2008 to that in 2012?
Offer a very short reply. 0.87. What is the ratio of the Production index(2004-2006) in Sao Tome and Principe in 2008 to that in 2012?
Give a very brief answer. 0.99. What is the ratio of the Production index(2004-2006) in Slovenia in 2008 to that in 2012?
Make the answer very short. 1.09. What is the ratio of the Production index(2004-2006) in High income in 2008 to that in 2013?
Your answer should be very brief. 0.96. What is the ratio of the Production index(2004-2006) in Australia in 2008 to that in 2013?
Offer a very short reply. 0.87. What is the ratio of the Production index(2004-2006) of Sao Tome and Principe in 2008 to that in 2013?
Make the answer very short. 0.91. What is the ratio of the Production index(2004-2006) of Slovenia in 2008 to that in 2013?
Provide a short and direct response. 1.15. What is the ratio of the Production index(2004-2006) of High income in 2009 to that in 2010?
Your answer should be compact. 1. What is the ratio of the Production index(2004-2006) in Australia in 2009 to that in 2010?
Keep it short and to the point. 1.03. What is the ratio of the Production index(2004-2006) of Sao Tome and Principe in 2009 to that in 2010?
Your answer should be compact. 1.01. What is the ratio of the Production index(2004-2006) in Slovenia in 2009 to that in 2010?
Your answer should be compact. 0.98. What is the ratio of the Production index(2004-2006) of High income in 2009 to that in 2011?
Provide a succinct answer. 0.98. What is the ratio of the Production index(2004-2006) of Australia in 2009 to that in 2011?
Provide a short and direct response. 0.96. What is the ratio of the Production index(2004-2006) in Sao Tome and Principe in 2009 to that in 2011?
Offer a very short reply. 1.03. What is the ratio of the Production index(2004-2006) in Australia in 2009 to that in 2012?
Provide a succinct answer. 0.88. What is the ratio of the Production index(2004-2006) of Sao Tome and Principe in 2009 to that in 2012?
Ensure brevity in your answer.  1.01. What is the ratio of the Production index(2004-2006) in Slovenia in 2009 to that in 2012?
Offer a terse response. 1.06. What is the ratio of the Production index(2004-2006) in Australia in 2009 to that in 2013?
Make the answer very short. 0.88. What is the ratio of the Production index(2004-2006) of Sao Tome and Principe in 2009 to that in 2013?
Offer a terse response. 0.93. What is the ratio of the Production index(2004-2006) of Slovenia in 2009 to that in 2013?
Provide a short and direct response. 1.11. What is the ratio of the Production index(2004-2006) in High income in 2010 to that in 2011?
Make the answer very short. 0.98. What is the ratio of the Production index(2004-2006) in Australia in 2010 to that in 2011?
Your answer should be very brief. 0.94. What is the ratio of the Production index(2004-2006) in Sao Tome and Principe in 2010 to that in 2011?
Offer a very short reply. 1.02. What is the ratio of the Production index(2004-2006) in Slovenia in 2010 to that in 2011?
Your answer should be very brief. 1.03. What is the ratio of the Production index(2004-2006) in Australia in 2010 to that in 2012?
Your response must be concise. 0.85. What is the ratio of the Production index(2004-2006) of Slovenia in 2010 to that in 2012?
Offer a very short reply. 1.08. What is the ratio of the Production index(2004-2006) in Australia in 2010 to that in 2013?
Offer a terse response. 0.85. What is the ratio of the Production index(2004-2006) in Sao Tome and Principe in 2010 to that in 2013?
Offer a very short reply. 0.92. What is the ratio of the Production index(2004-2006) in Slovenia in 2010 to that in 2013?
Ensure brevity in your answer.  1.14. What is the ratio of the Production index(2004-2006) in High income in 2011 to that in 2012?
Ensure brevity in your answer.  1.01. What is the ratio of the Production index(2004-2006) in Australia in 2011 to that in 2012?
Keep it short and to the point. 0.91. What is the ratio of the Production index(2004-2006) of Sao Tome and Principe in 2011 to that in 2012?
Offer a very short reply. 0.98. What is the ratio of the Production index(2004-2006) in Slovenia in 2011 to that in 2012?
Your answer should be compact. 1.06. What is the ratio of the Production index(2004-2006) of High income in 2011 to that in 2013?
Your answer should be very brief. 0.98. What is the ratio of the Production index(2004-2006) of Australia in 2011 to that in 2013?
Your response must be concise. 0.91. What is the ratio of the Production index(2004-2006) of Sao Tome and Principe in 2011 to that in 2013?
Offer a terse response. 0.9. What is the ratio of the Production index(2004-2006) of Slovenia in 2011 to that in 2013?
Provide a short and direct response. 1.11. What is the ratio of the Production index(2004-2006) in High income in 2012 to that in 2013?
Ensure brevity in your answer.  0.96. What is the ratio of the Production index(2004-2006) of Sao Tome and Principe in 2012 to that in 2013?
Your answer should be compact. 0.92. What is the ratio of the Production index(2004-2006) in Slovenia in 2012 to that in 2013?
Provide a succinct answer. 1.05. What is the difference between the highest and the second highest Production index(2004-2006) in High income?
Ensure brevity in your answer.  2.64. What is the difference between the highest and the second highest Production index(2004-2006) of Australia?
Your answer should be very brief. 0.02. What is the difference between the highest and the second highest Production index(2004-2006) of Sao Tome and Principe?
Keep it short and to the point. 8.15. What is the difference between the highest and the lowest Production index(2004-2006) in High income?
Keep it short and to the point. 9.81. What is the difference between the highest and the lowest Production index(2004-2006) in Australia?
Make the answer very short. 28.06. What is the difference between the highest and the lowest Production index(2004-2006) of Sao Tome and Principe?
Ensure brevity in your answer.  11.26. What is the difference between the highest and the lowest Production index(2004-2006) in Slovenia?
Keep it short and to the point. 13.26. 